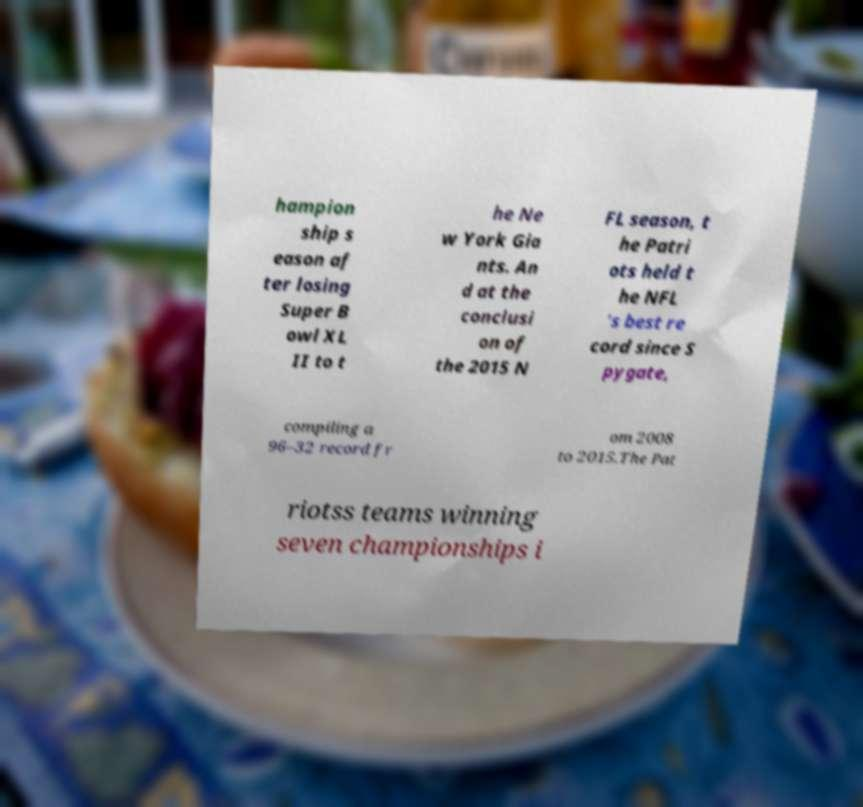Please read and relay the text visible in this image. What does it say? hampion ship s eason af ter losing Super B owl XL II to t he Ne w York Gia nts. An d at the conclusi on of the 2015 N FL season, t he Patri ots held t he NFL 's best re cord since S pygate, compiling a 96–32 record fr om 2008 to 2015.The Pat riotss teams winning seven championships i 